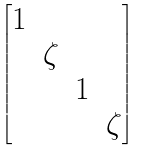Convert formula to latex. <formula><loc_0><loc_0><loc_500><loc_500>\begin{bmatrix} 1 \\ & \zeta \\ & & 1 \\ & & & \zeta \end{bmatrix}</formula> 